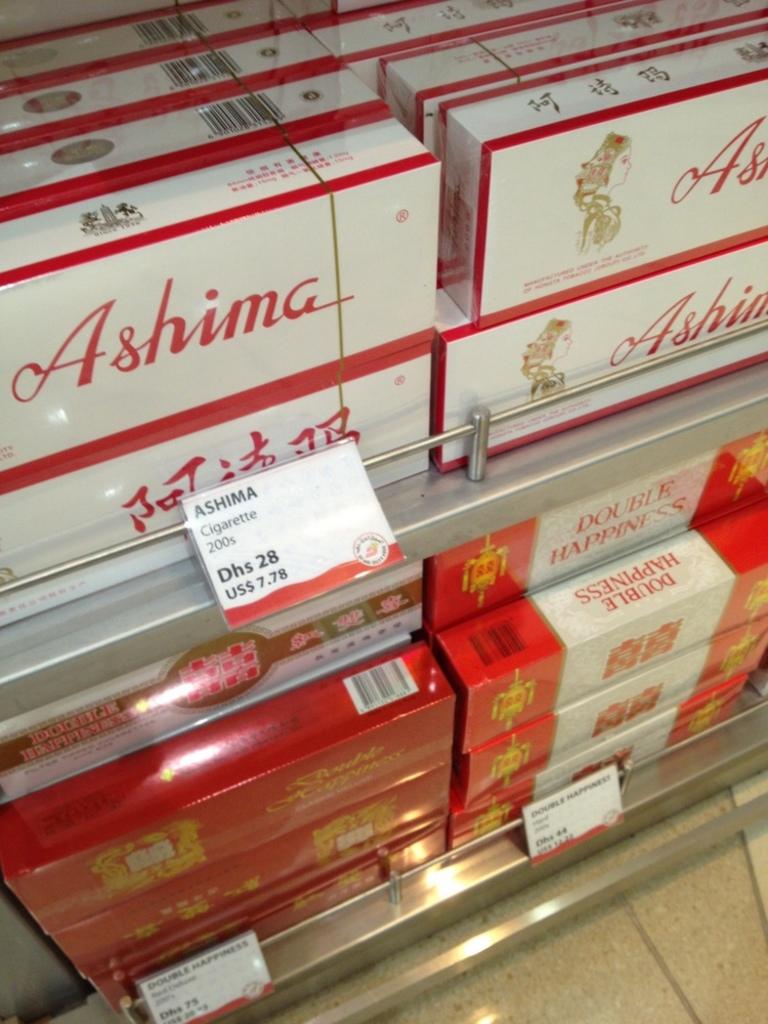How much do they cost?
Your response must be concise. $7.78. 